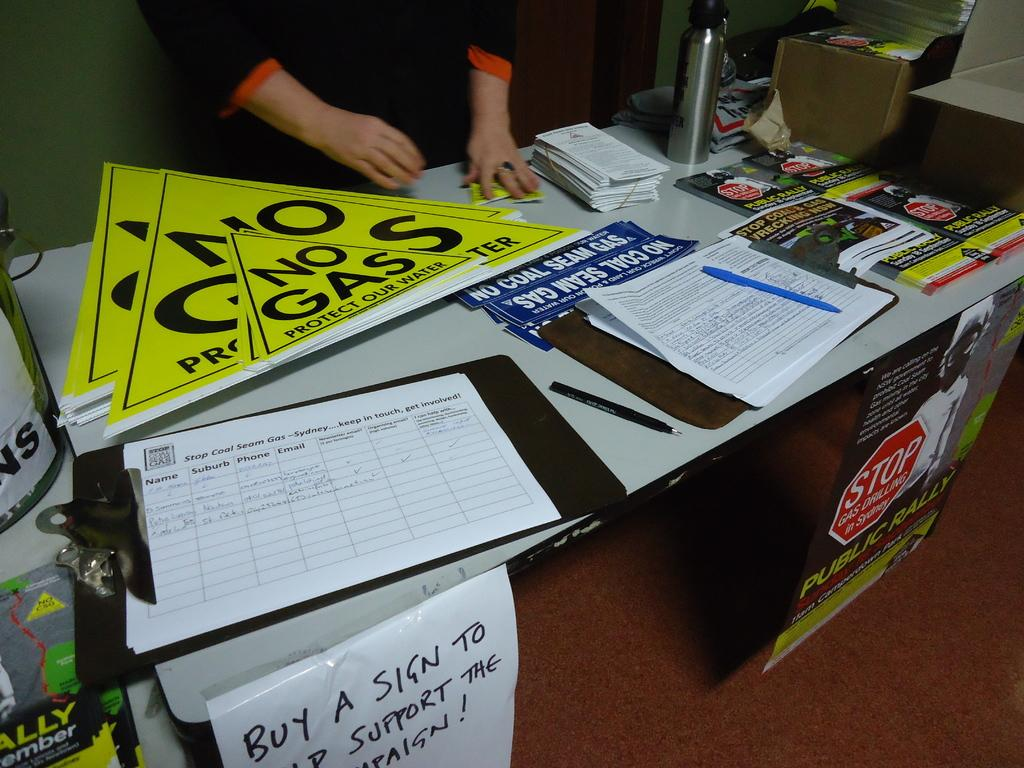<image>
Create a compact narrative representing the image presented. A table displaying NO GAS signs and a form to sign to support the campaign. 